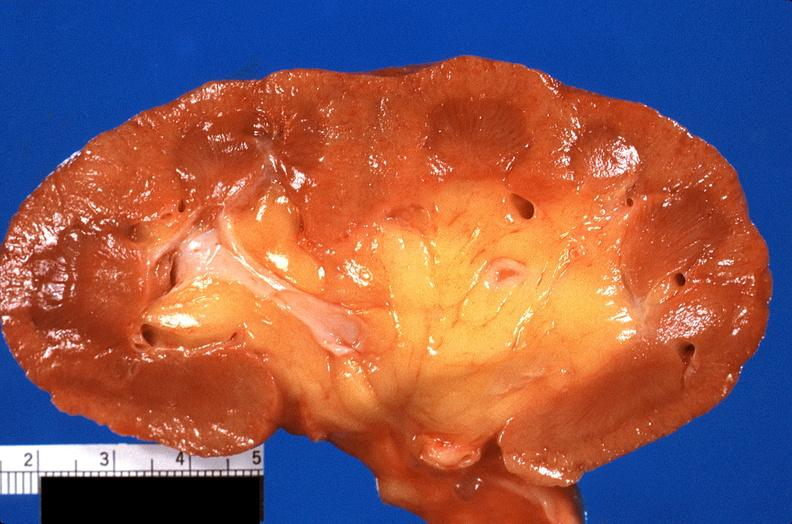what does this image show?
Answer the question using a single word or phrase. Kidney 